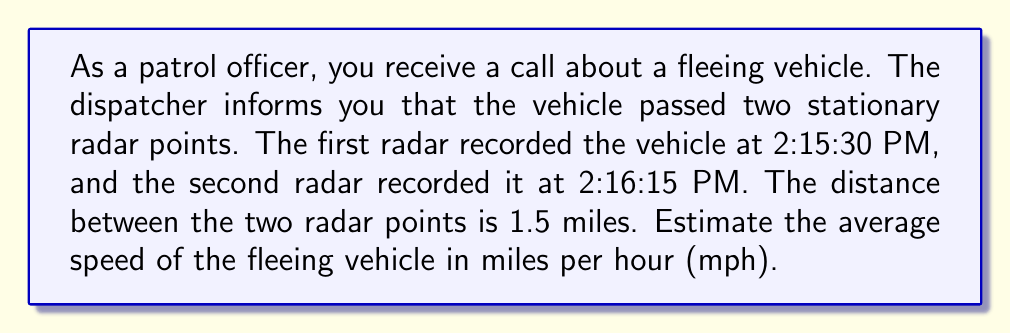Provide a solution to this math problem. To solve this inverse problem and estimate the speed of the fleeing vehicle, we'll follow these steps:

1. Calculate the time difference between the two radar recordings:
   2:16:15 PM - 2:15:30 PM = 45 seconds
   
   Convert this to hours:
   $$ \text{Time (hours)} = \frac{45 \text{ seconds}}{3600 \text{ seconds/hour}} = 0.0125 \text{ hours} $$

2. Use the distance formula to calculate the average speed:
   $$ \text{Speed} = \frac{\text{Distance}}{\text{Time}} $$

3. Plug in the known values:
   $$ \text{Speed} = \frac{1.5 \text{ miles}}{0.0125 \text{ hours}} $$

4. Perform the calculation:
   $$ \text{Speed} = 120 \text{ miles per hour} $$

This calculation provides an estimate of the average speed of the fleeing vehicle based on the limited observations from the two radar points.
Answer: 120 mph 